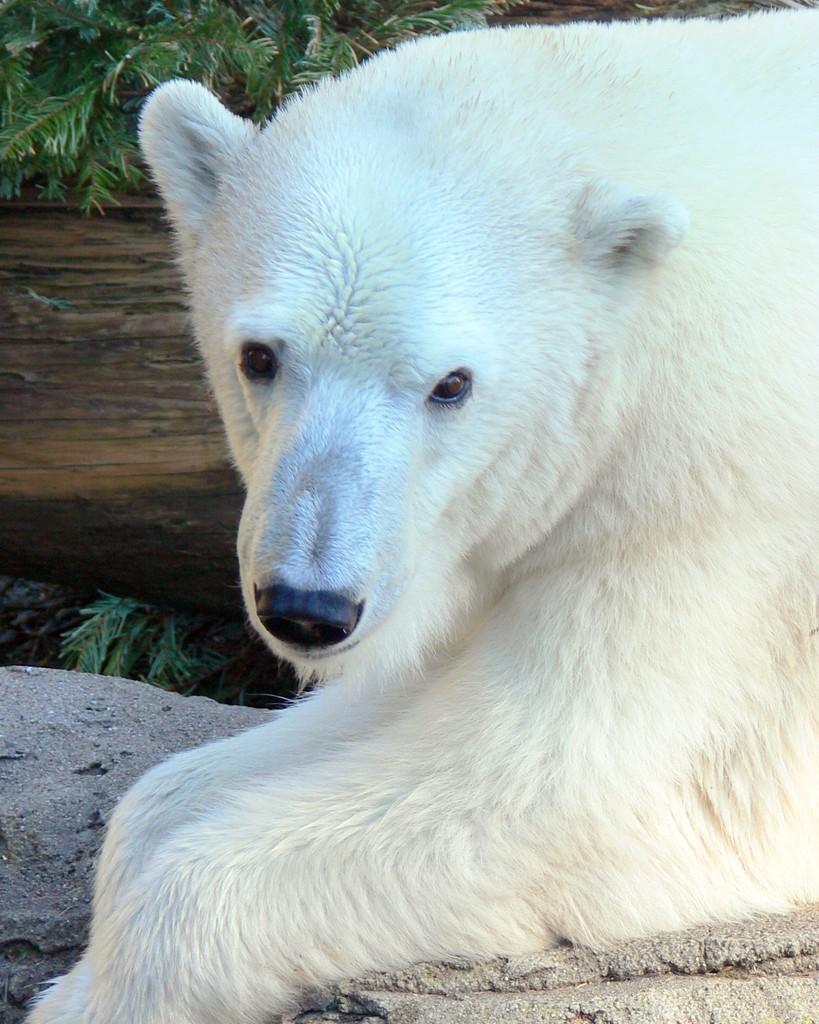Could you give a brief overview of what you see in this image? In this image I can see on the right side there is an animal in white color. On the left side there are plants. 